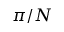Convert formula to latex. <formula><loc_0><loc_0><loc_500><loc_500>\pi / N</formula> 